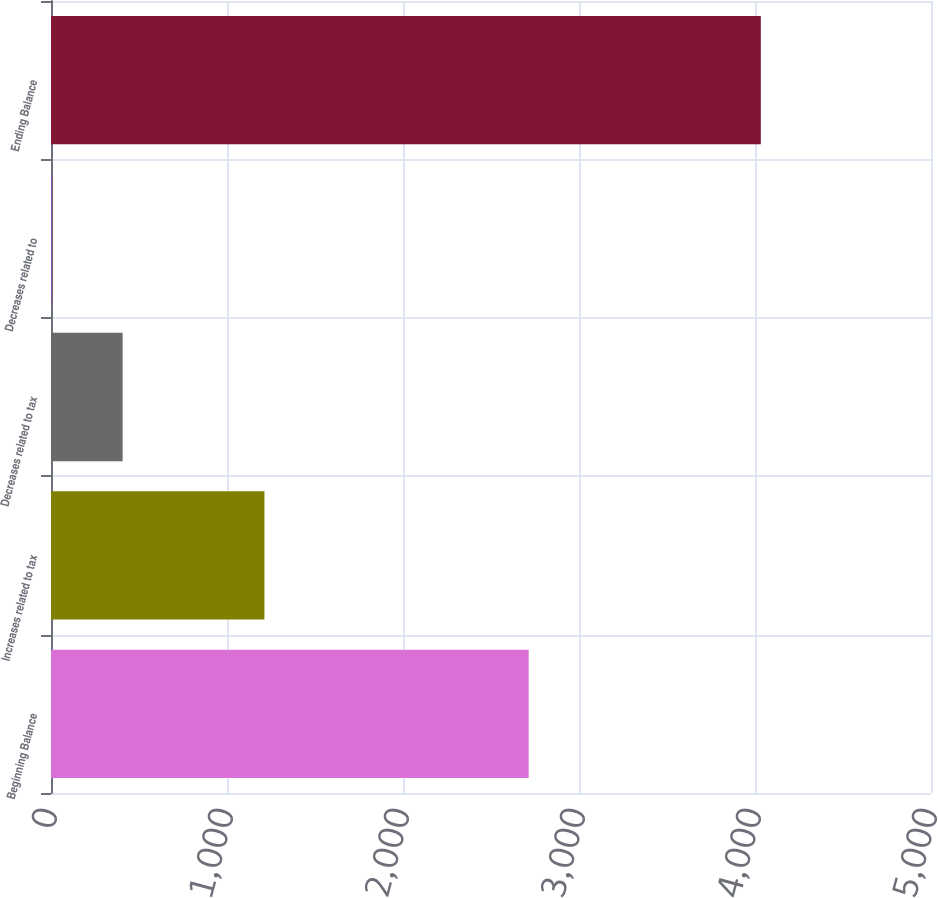Convert chart. <chart><loc_0><loc_0><loc_500><loc_500><bar_chart><fcel>Beginning Balance<fcel>Increases related to tax<fcel>Decreases related to tax<fcel>Decreases related to<fcel>Ending Balance<nl><fcel>2714<fcel>1212.7<fcel>406.9<fcel>4<fcel>4033<nl></chart> 